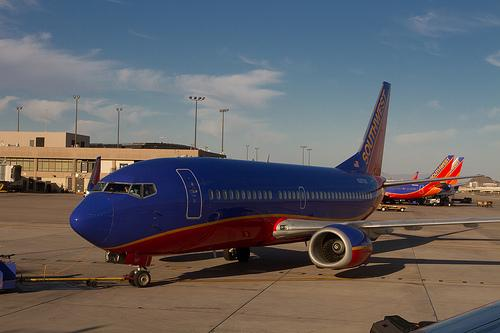Create a brief sentence highlighting the main color theme and subject of the image. A red and blue Southwest airplane catches the eye as it awaits departure on the airport tarmac. Mention the most eye-catching parts of the airplane in the image. The airplane's jet engine, vibrant blue and red colors, gold "Southwest" lettering, cockpit windows, passenger windows, and landing gears are noticeable features. Summarize the key features of the airport environment in the image. The airport scene includes a yellow-striped runway, large silver airport light, grey building, tall light-posts, and a blue sky. What kind of vehicle is prominently visible in the image? Add some descriptive details. A blue and red airplane, with a silver wing and a company logo on its tail, is waiting on the tarmac at an airport, displaying passenger windows, landing wheels, and engines. Describe the environment and scene with a focus on the airline company. In an airport setting, a Southwest Airlines plane, adorned with blue, red, and gold colors, stands at tarmac, showcasing the word "Southwest" in gold letters on its tail. Elaborate on some distinct features of the airplane in the image. The airplane in the image displays company branding, a unique color scheme, and various markings, such as writing on the plane's tail and front door. Comment on the prominence of the airline company elements in the image. The logo and gold "Southwest" letters on the tail of the airplane are clearly visible, highlighting the airline company's presence in the image. Provide a concise overview of the central object and surrounding context in the image. The image showcases an airplane with distinctive blue and red coloring, waiting on the airport tarmac alongside a grey building and yellow-striped runway. Briefly mention the color and main elements found within the image. The image features a red and blue Southwest airplane with engines, windows, and doors on the tarmac near a grey airport building and yellow-striped runway. Write a description focusing on the plane's engines and wings. The image displays an airplane with blue and red jet engines, as well as silver wings, showcasing its vibrant and powerful design. 